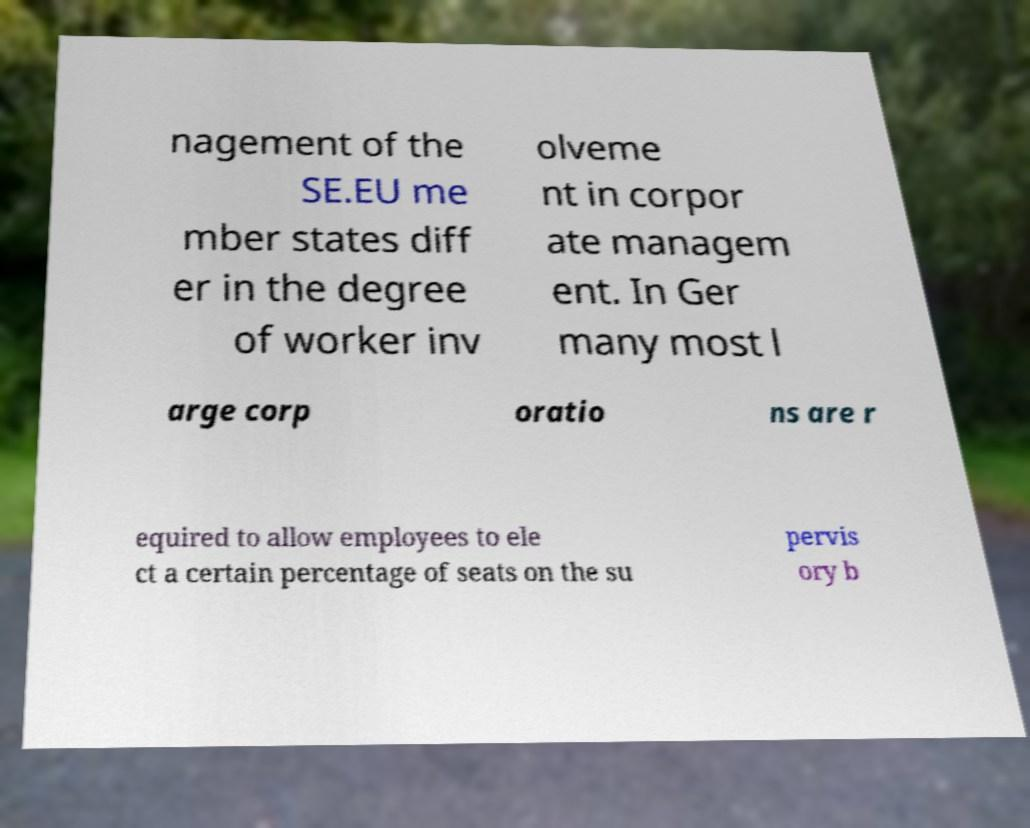Please read and relay the text visible in this image. What does it say? nagement of the SE.EU me mber states diff er in the degree of worker inv olveme nt in corpor ate managem ent. In Ger many most l arge corp oratio ns are r equired to allow employees to ele ct a certain percentage of seats on the su pervis ory b 